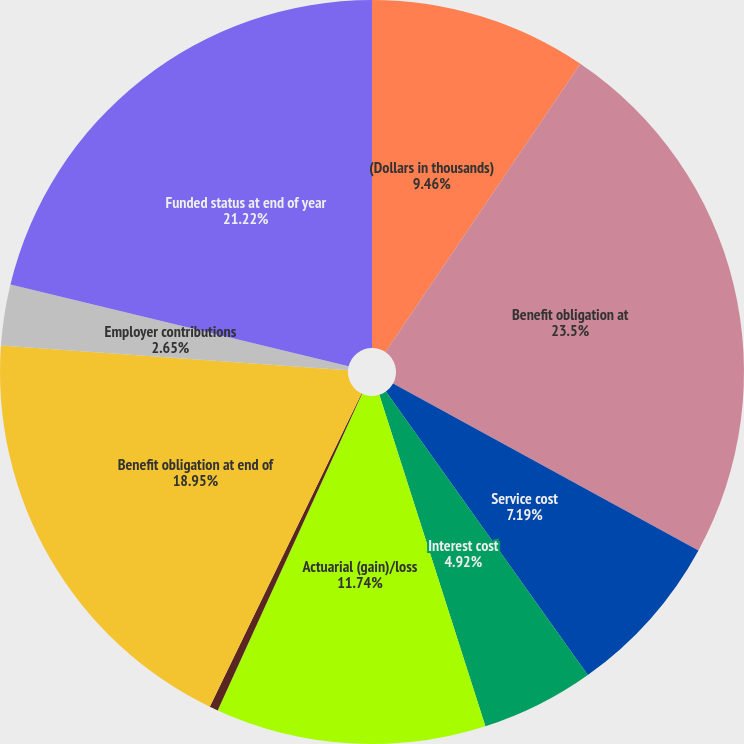Convert chart to OTSL. <chart><loc_0><loc_0><loc_500><loc_500><pie_chart><fcel>(Dollars in thousands)<fcel>Benefit obligation at<fcel>Service cost<fcel>Interest cost<fcel>Actuarial (gain)/loss<fcel>Benefits paid<fcel>Benefit obligation at end of<fcel>Employer contributions<fcel>Funded status at end of year<nl><fcel>9.46%<fcel>23.5%<fcel>7.19%<fcel>4.92%<fcel>11.74%<fcel>0.37%<fcel>18.95%<fcel>2.65%<fcel>21.22%<nl></chart> 